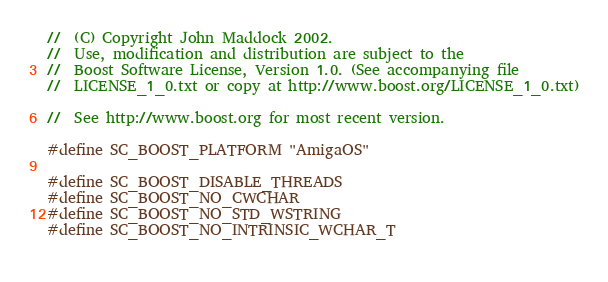<code> <loc_0><loc_0><loc_500><loc_500><_C++_>//  (C) Copyright John Maddock 2002. 
//  Use, modification and distribution are subject to the 
//  Boost Software License, Version 1.0. (See accompanying file 
//  LICENSE_1_0.txt or copy at http://www.boost.org/LICENSE_1_0.txt)

//  See http://www.boost.org for most recent version.

#define SC_BOOST_PLATFORM "AmigaOS"

#define SC_BOOST_DISABLE_THREADS
#define SC_BOOST_NO_CWCHAR
#define SC_BOOST_NO_STD_WSTRING
#define SC_BOOST_NO_INTRINSIC_WCHAR_T
 

</code> 